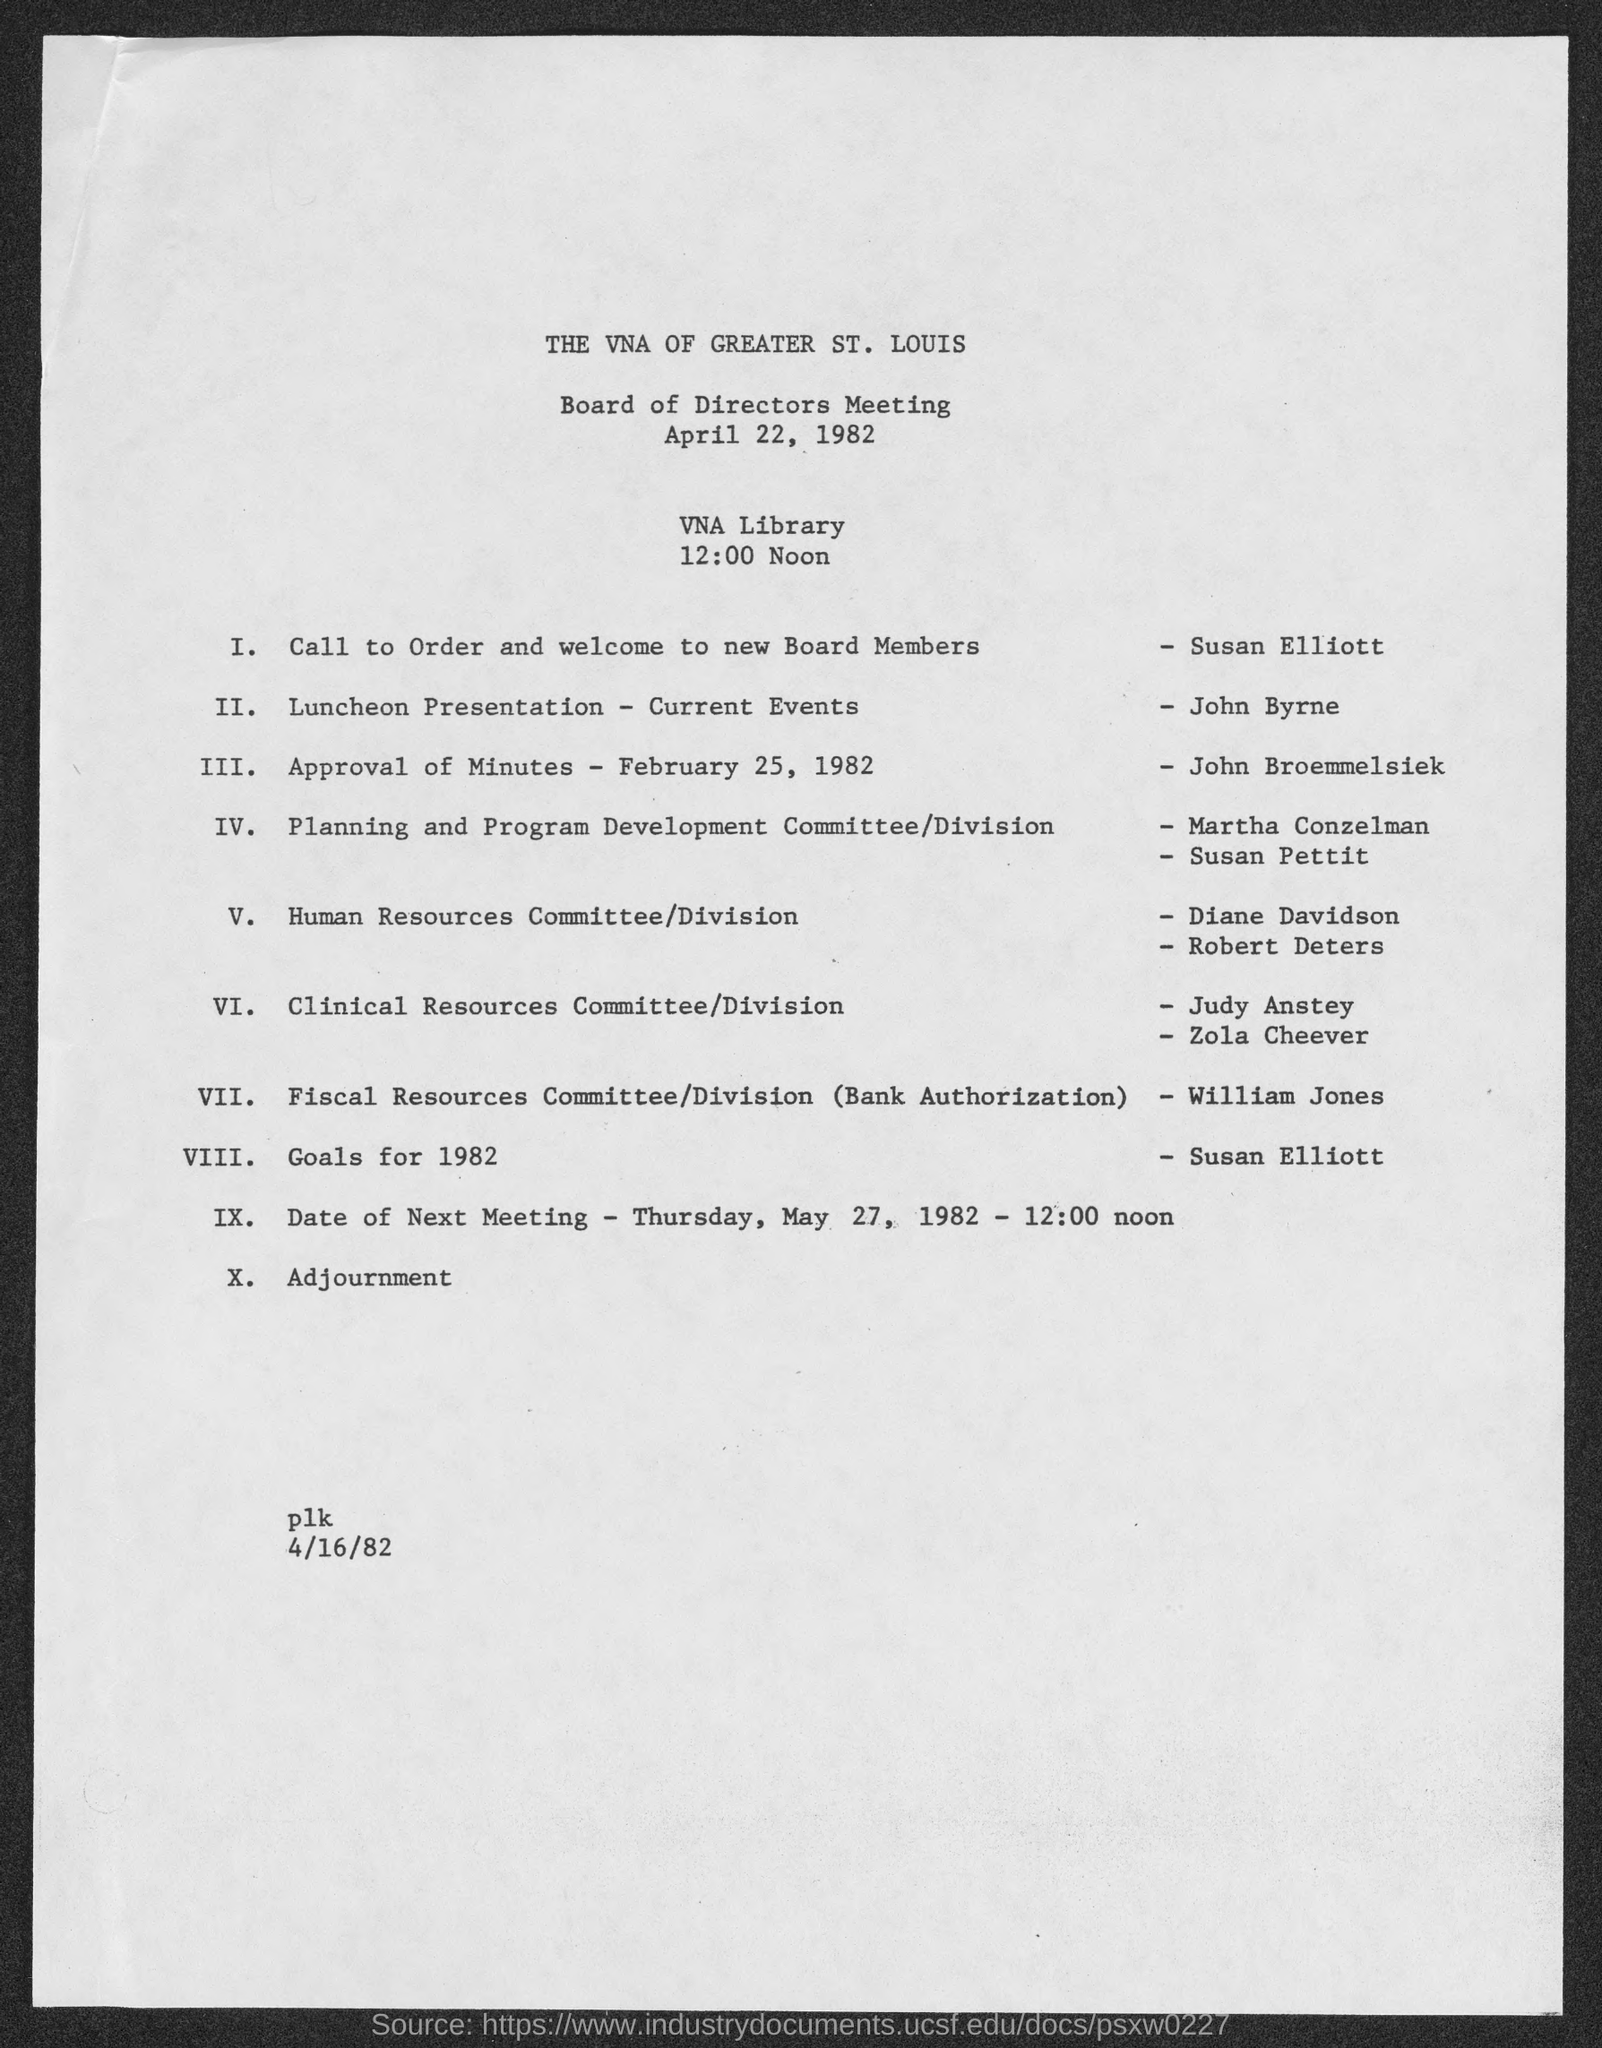Highlight a few significant elements in this photo. John Broemmelsiek's duty is to approve the minutes. In 1982, Susan Elliott was the speaker who discussed goals. The next meeting will take place on May 27, 1982. The meeting is going to be held at 12:00 Noon. The meeting will take place at the VNA library. 